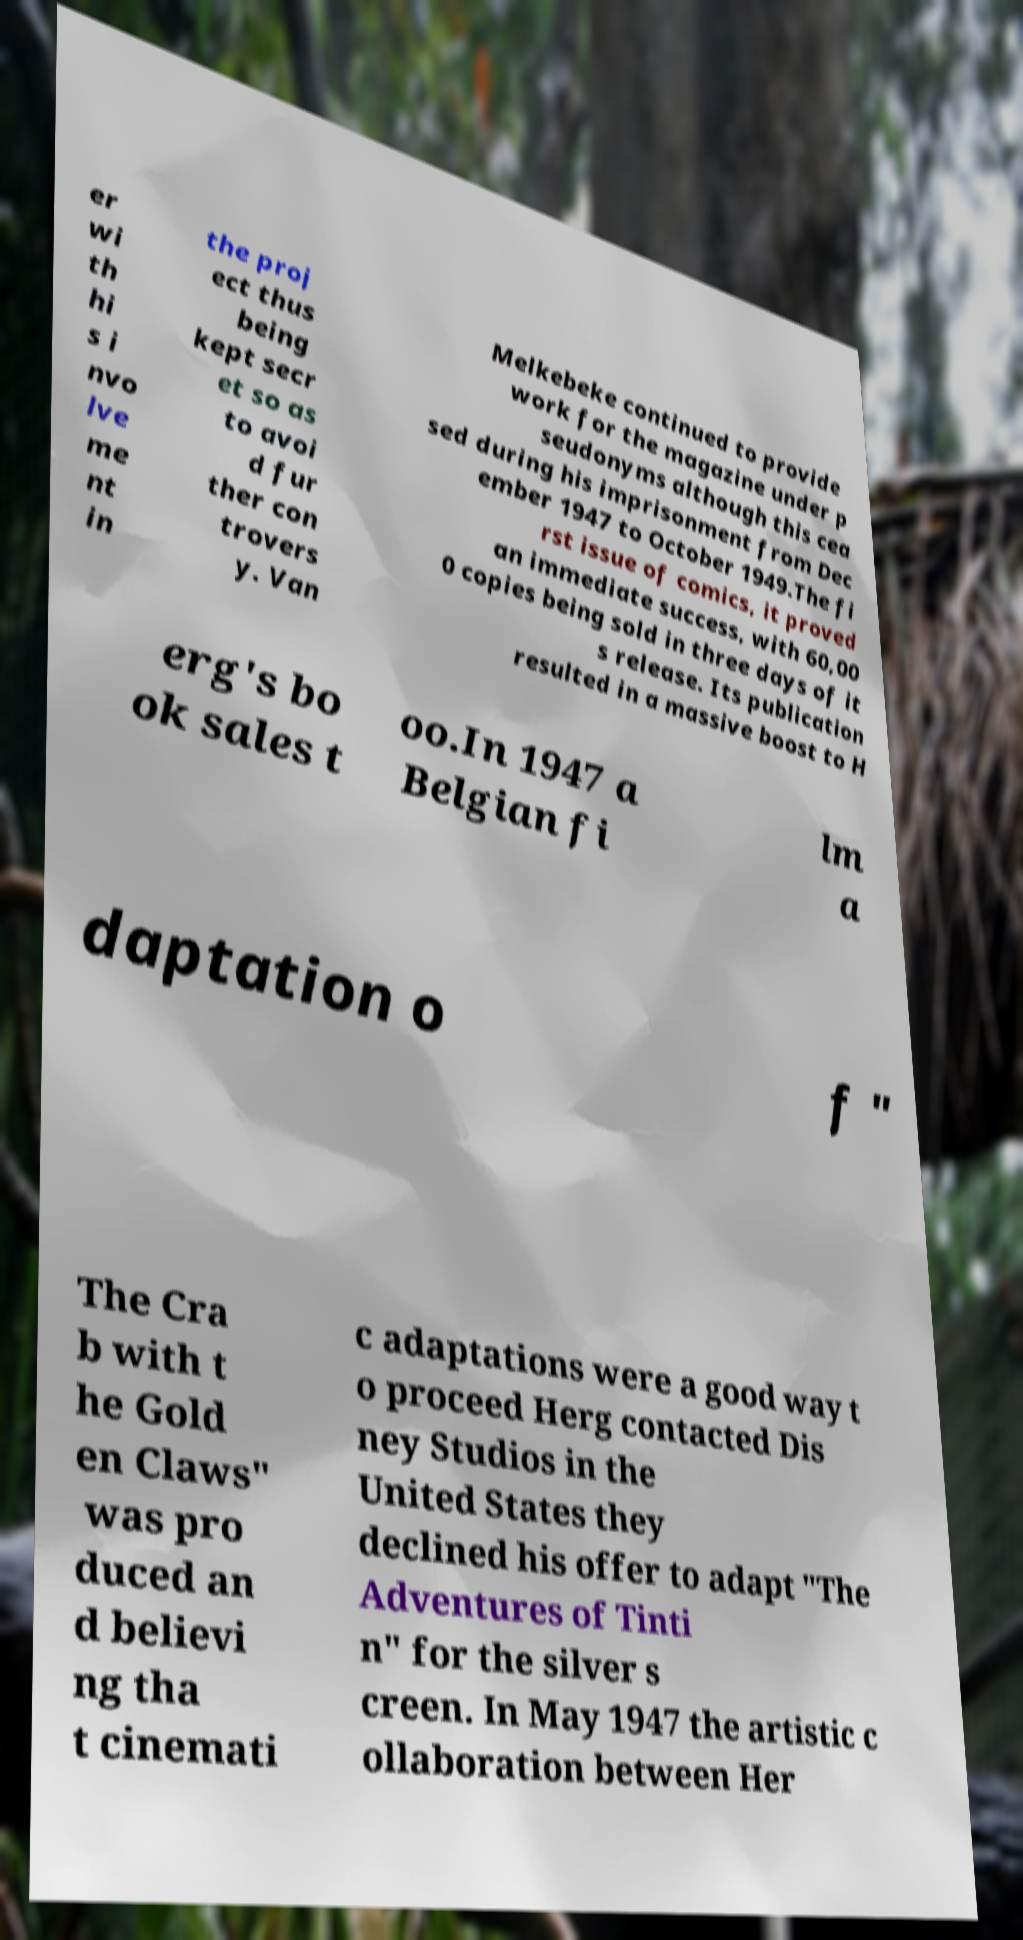Could you assist in decoding the text presented in this image and type it out clearly? er wi th hi s i nvo lve me nt in the proj ect thus being kept secr et so as to avoi d fur ther con trovers y. Van Melkebeke continued to provide work for the magazine under p seudonyms although this cea sed during his imprisonment from Dec ember 1947 to October 1949.The fi rst issue of comics, it proved an immediate success, with 60,00 0 copies being sold in three days of it s release. Its publication resulted in a massive boost to H erg's bo ok sales t oo.In 1947 a Belgian fi lm a daptation o f " The Cra b with t he Gold en Claws" was pro duced an d believi ng tha t cinemati c adaptations were a good way t o proceed Herg contacted Dis ney Studios in the United States they declined his offer to adapt "The Adventures of Tinti n" for the silver s creen. In May 1947 the artistic c ollaboration between Her 